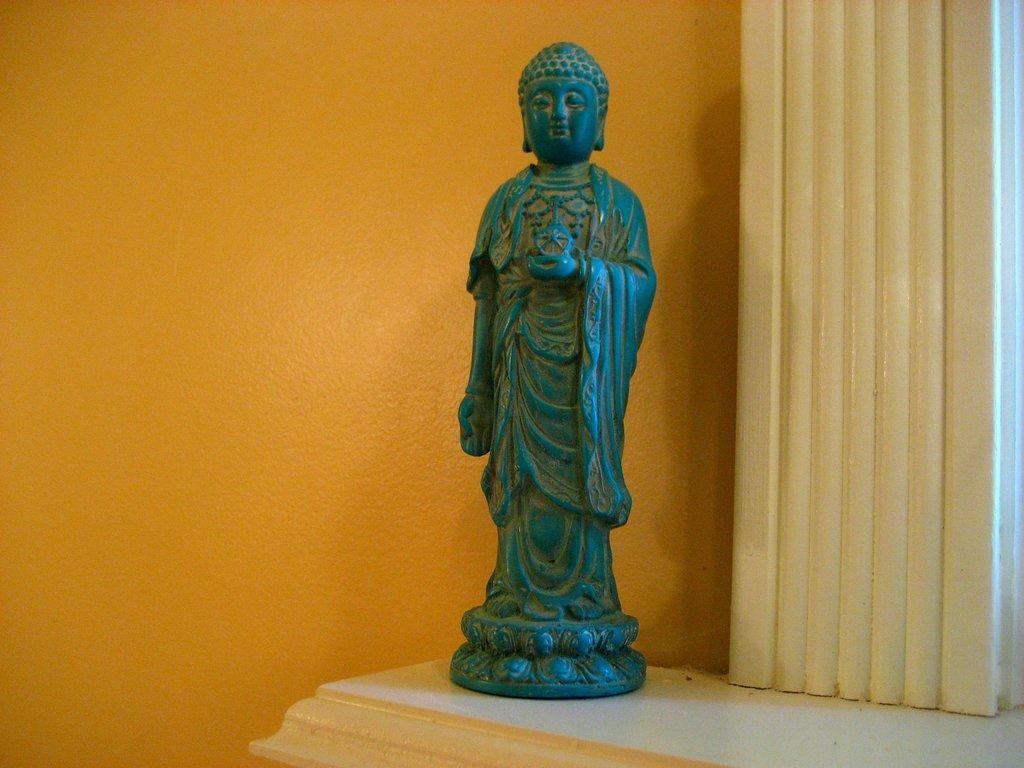How would you summarize this image in a sentence or two? In this image in the center there is one statue, and in the background there is wall. At the bottom it looks like a table, and on the right side of the image there is pillar. 